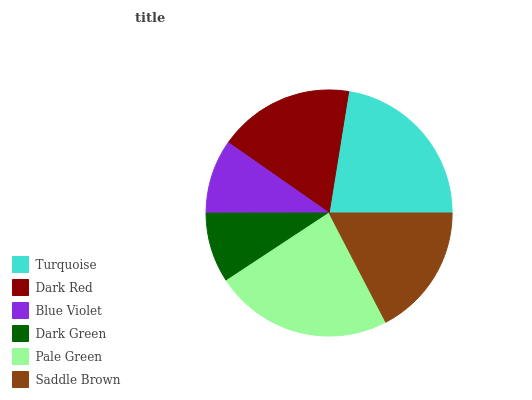Is Dark Green the minimum?
Answer yes or no. Yes. Is Pale Green the maximum?
Answer yes or no. Yes. Is Dark Red the minimum?
Answer yes or no. No. Is Dark Red the maximum?
Answer yes or no. No. Is Turquoise greater than Dark Red?
Answer yes or no. Yes. Is Dark Red less than Turquoise?
Answer yes or no. Yes. Is Dark Red greater than Turquoise?
Answer yes or no. No. Is Turquoise less than Dark Red?
Answer yes or no. No. Is Dark Red the high median?
Answer yes or no. Yes. Is Saddle Brown the low median?
Answer yes or no. Yes. Is Dark Green the high median?
Answer yes or no. No. Is Pale Green the low median?
Answer yes or no. No. 